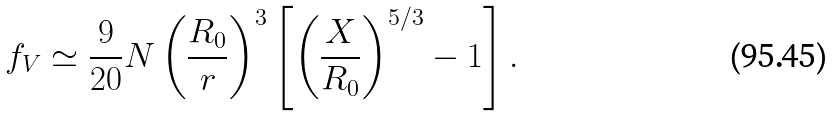<formula> <loc_0><loc_0><loc_500><loc_500>f _ { V } \simeq \frac { 9 } { 2 0 } N \left ( \frac { R _ { 0 } } { r } \right ) ^ { 3 } \left [ \left ( \frac { X } { R _ { 0 } } \right ) ^ { 5 / 3 } - 1 \right ] .</formula> 